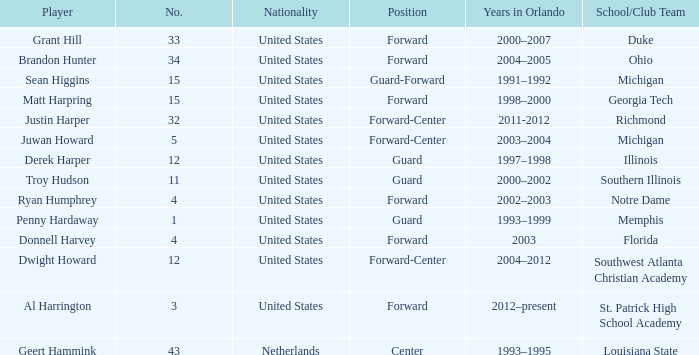What jersey number did Al Harrington wear 3.0. 